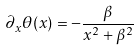Convert formula to latex. <formula><loc_0><loc_0><loc_500><loc_500>\partial _ { x } \theta ( x ) = - \frac { \beta } { x ^ { 2 } + \beta ^ { 2 } }</formula> 